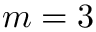Convert formula to latex. <formula><loc_0><loc_0><loc_500><loc_500>m = 3</formula> 